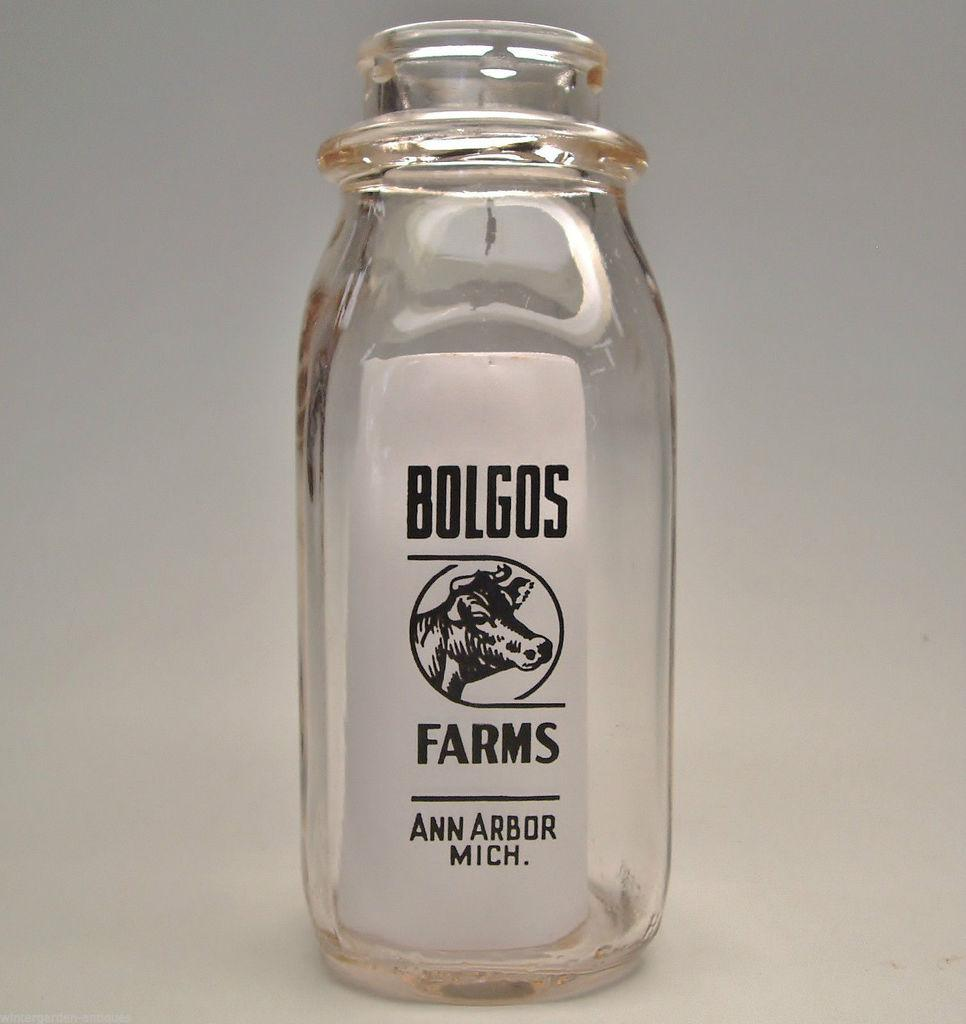Provide a one-sentence caption for the provided image. Bolgos farms from Ann Arbor Mich clear jar. 